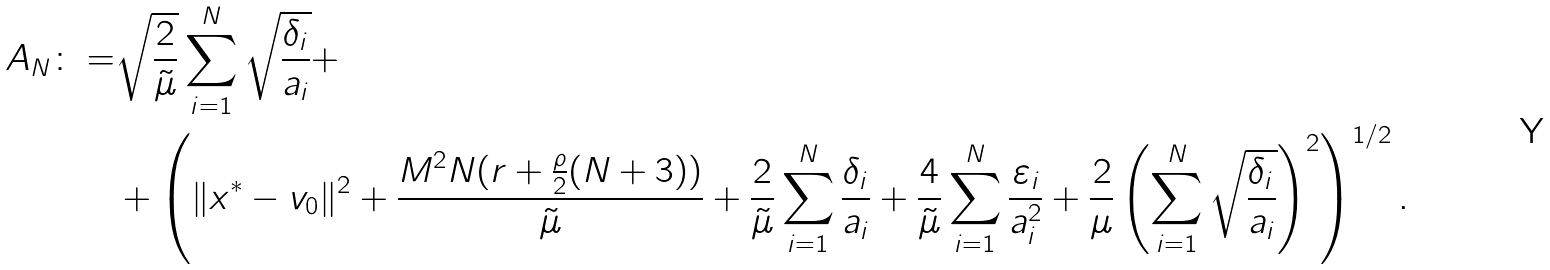<formula> <loc_0><loc_0><loc_500><loc_500>A _ { N } \colon = & \sqrt { \frac { 2 } { \tilde { \mu } } } \sum _ { i = 1 } ^ { N } \sqrt { \frac { \delta _ { i } } { a _ { i } } } + \\ & + \left ( \| x ^ { * } - v _ { 0 } \| ^ { 2 } + \frac { M ^ { 2 } N ( r + \frac { \rho } { 2 } ( N + 3 ) ) } { \tilde { \mu } } + \frac { 2 } { \tilde { \mu } } \sum ^ { N } _ { i = 1 } \frac { \delta _ { i } } { a _ { i } } + \frac { 4 } { \tilde { \mu } } \sum _ { i = 1 } ^ { N } \frac { \varepsilon _ { i } } { a _ { i } ^ { 2 } } + \frac { 2 } { \mu } \left ( \sum _ { i = 1 } ^ { N } \sqrt { \frac { \delta _ { i } } { a _ { i } } } \right ) ^ { 2 } \right ) ^ { 1 / 2 } .</formula> 